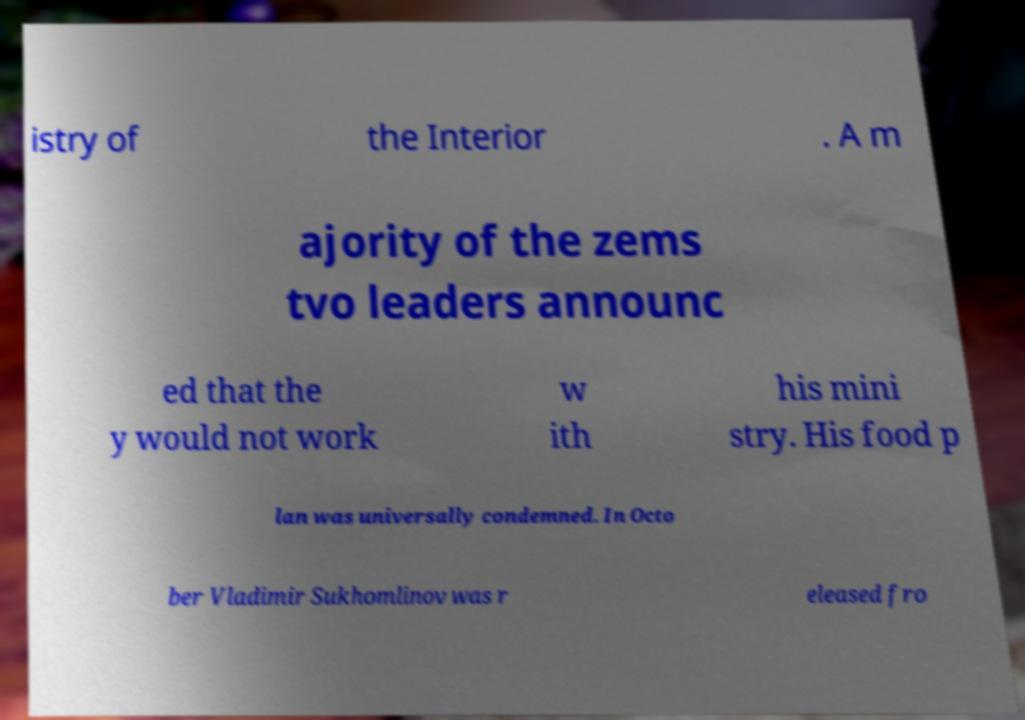There's text embedded in this image that I need extracted. Can you transcribe it verbatim? istry of the Interior . A m ajority of the zems tvo leaders announc ed that the y would not work w ith his mini stry. His food p lan was universally condemned. In Octo ber Vladimir Sukhomlinov was r eleased fro 